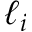<formula> <loc_0><loc_0><loc_500><loc_500>\ell _ { i }</formula> 